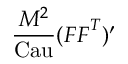Convert formula to latex. <formula><loc_0><loc_0><loc_500><loc_500>\frac { M ^ { 2 } } { C a u } ( { F } { F } ^ { T } ) ^ { \prime }</formula> 